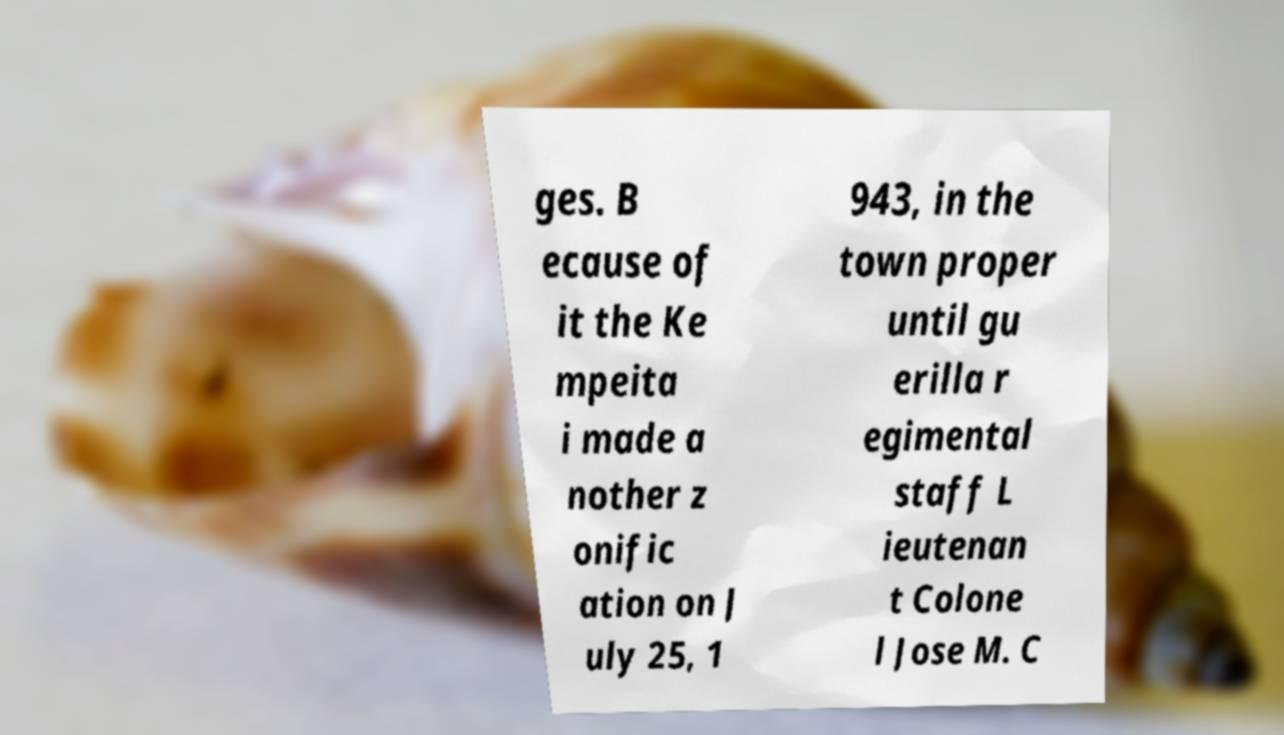What messages or text are displayed in this image? I need them in a readable, typed format. ges. B ecause of it the Ke mpeita i made a nother z onific ation on J uly 25, 1 943, in the town proper until gu erilla r egimental staff L ieutenan t Colone l Jose M. C 